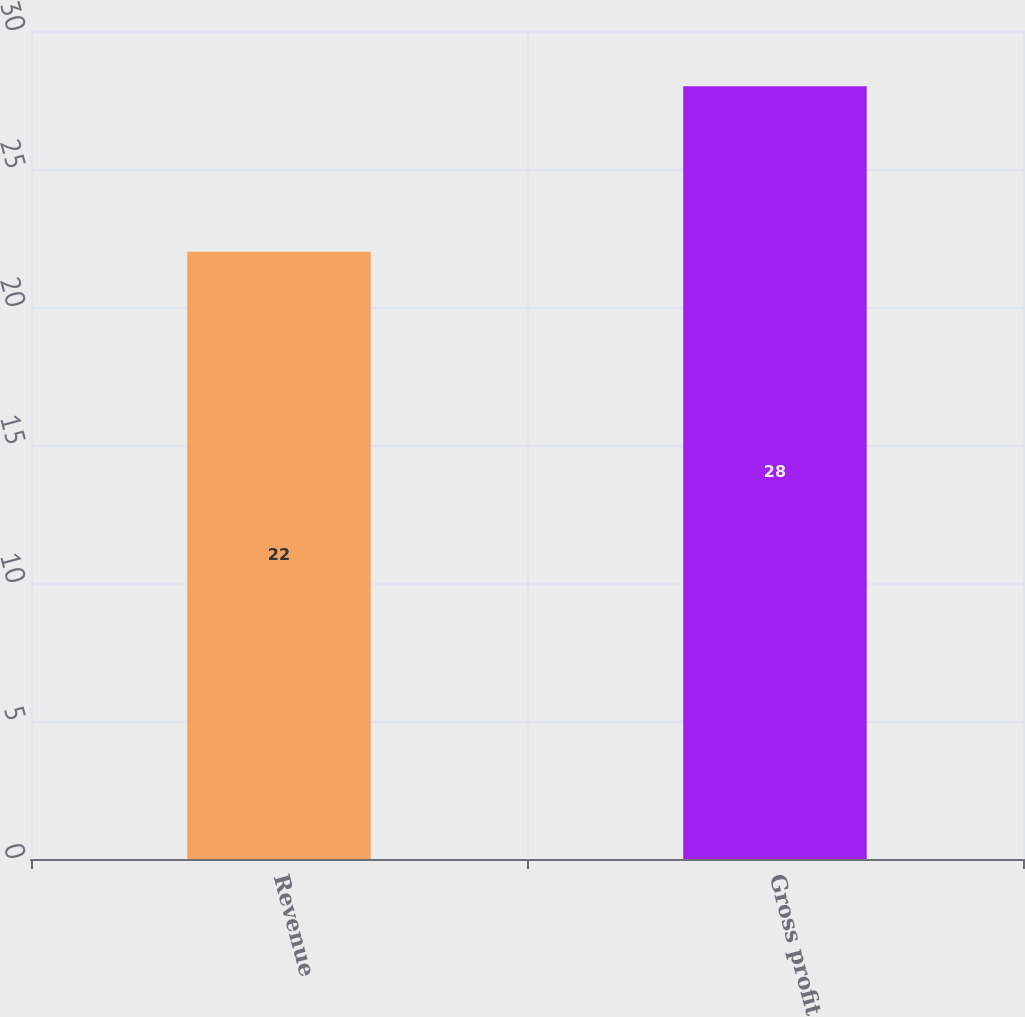Convert chart. <chart><loc_0><loc_0><loc_500><loc_500><bar_chart><fcel>Revenue<fcel>Gross profit<nl><fcel>22<fcel>28<nl></chart> 